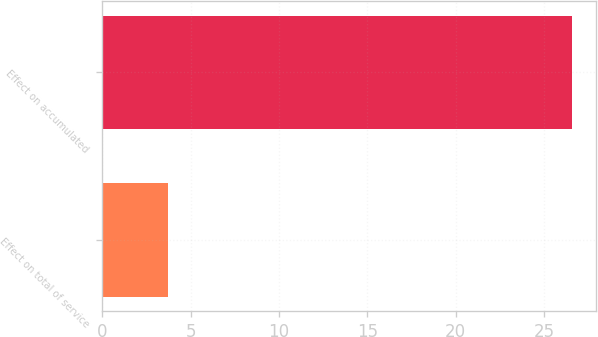<chart> <loc_0><loc_0><loc_500><loc_500><bar_chart><fcel>Effect on total of service<fcel>Effect on accumulated<nl><fcel>3.7<fcel>26.6<nl></chart> 